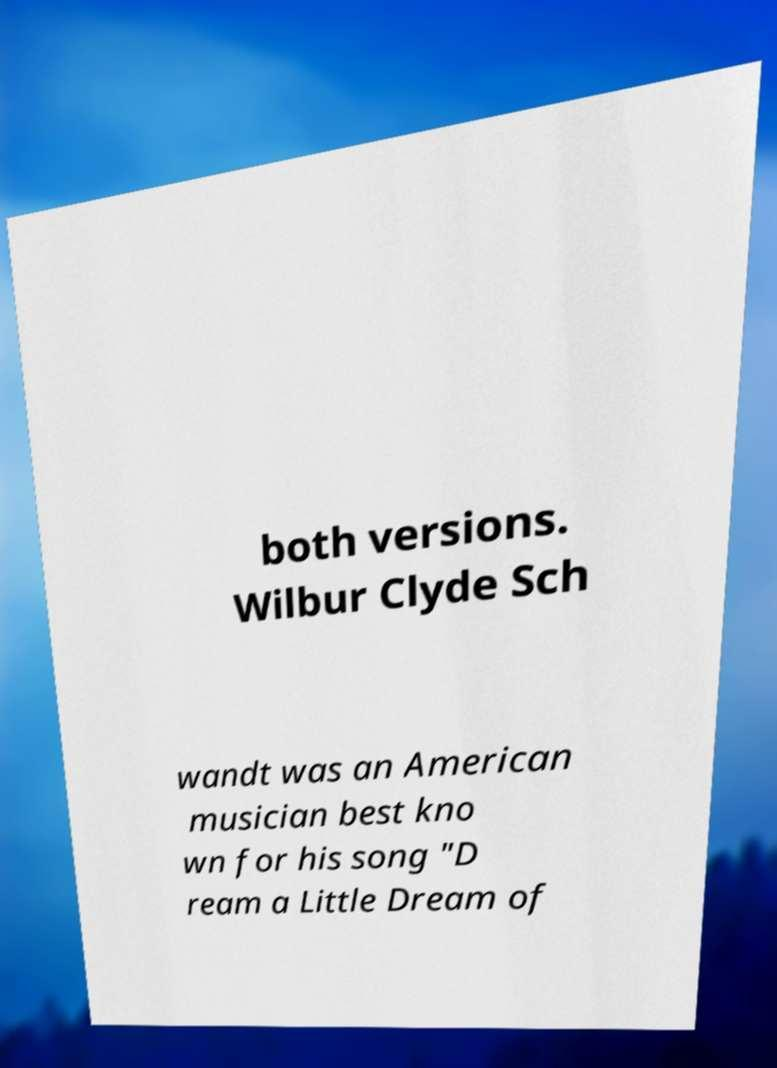I need the written content from this picture converted into text. Can you do that? both versions. Wilbur Clyde Sch wandt was an American musician best kno wn for his song "D ream a Little Dream of 